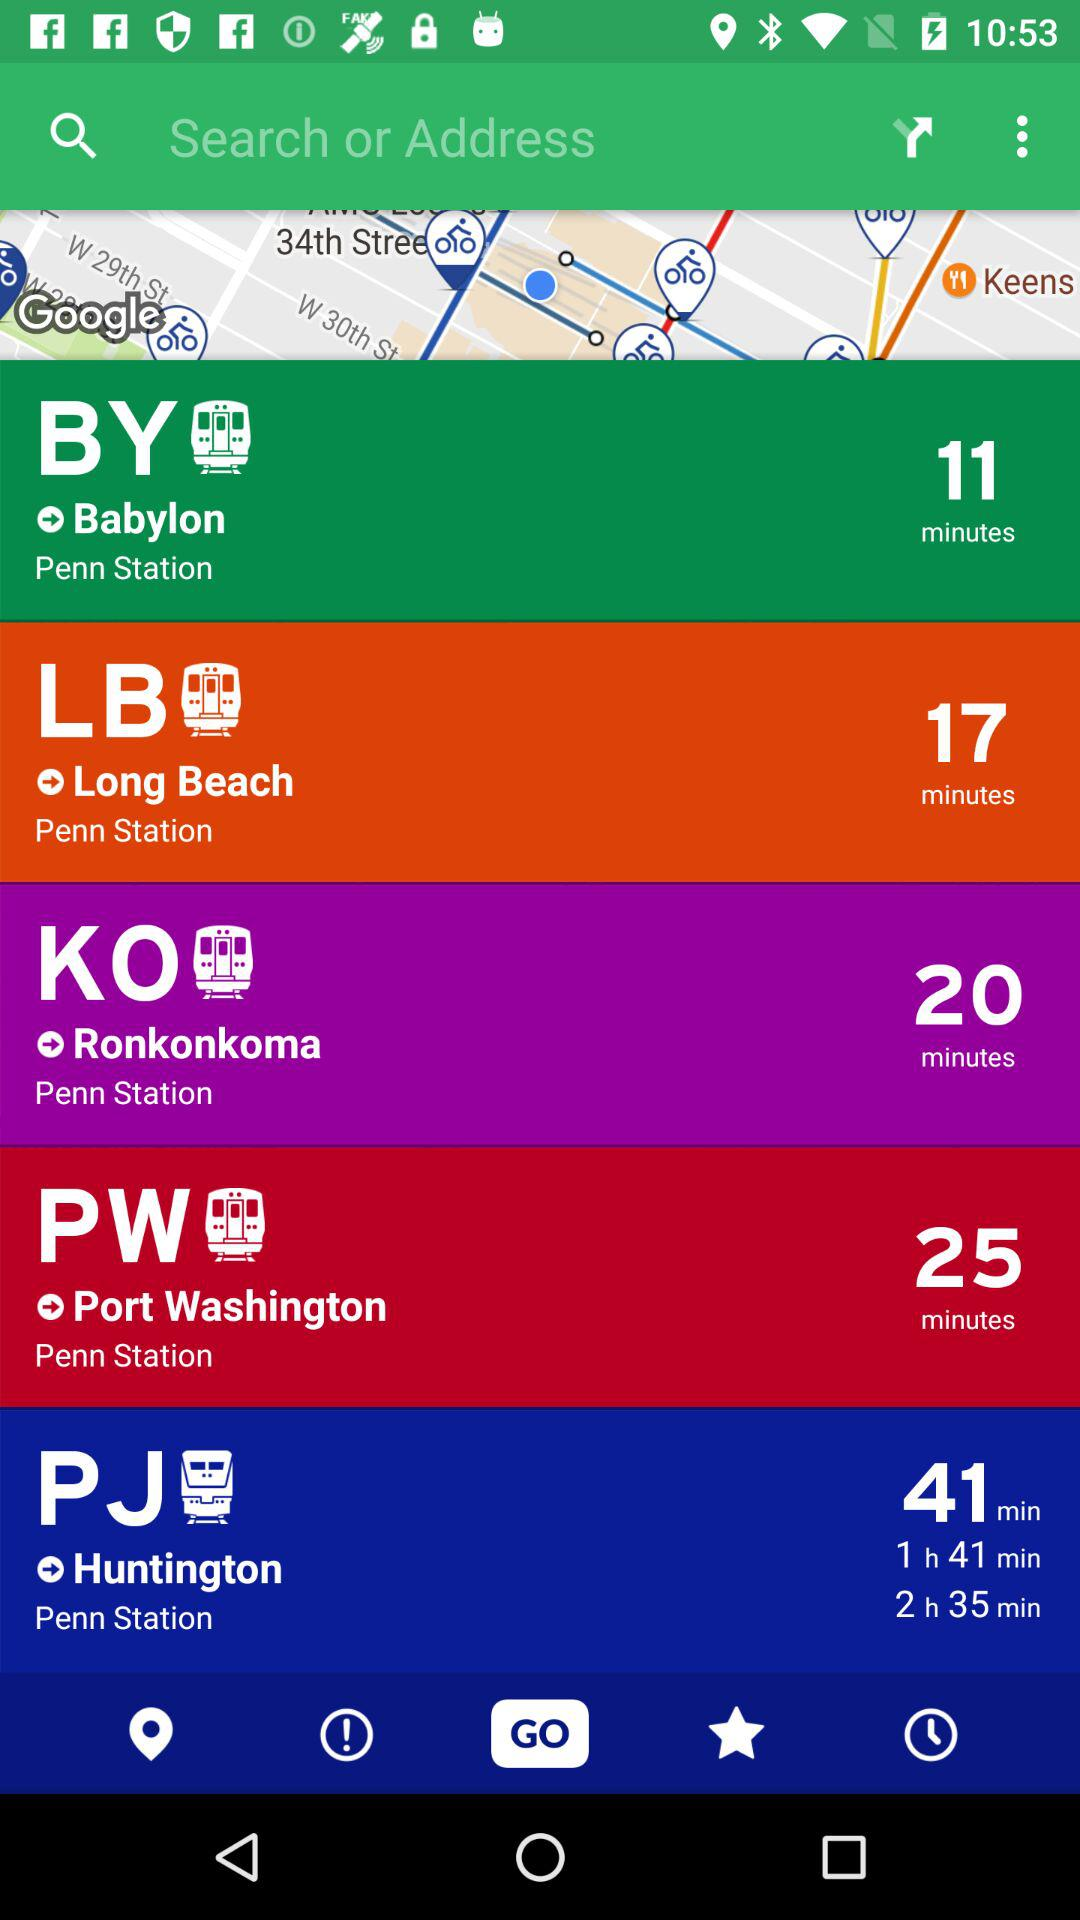How many train rides are there?
Answer the question using a single word or phrase. 5 